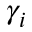Convert formula to latex. <formula><loc_0><loc_0><loc_500><loc_500>\gamma _ { i }</formula> 